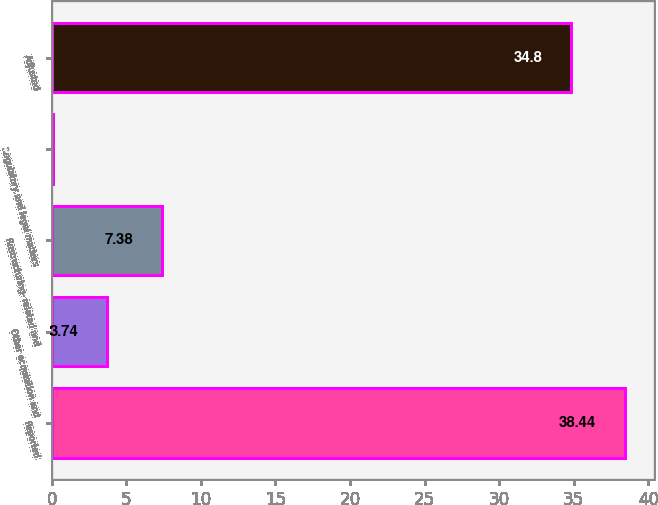<chart> <loc_0><loc_0><loc_500><loc_500><bar_chart><fcel>Reported<fcel>Other acquisition and<fcel>Restructuring- related and<fcel>Regulatory and legal matters<fcel>Adjusted<nl><fcel>38.44<fcel>3.74<fcel>7.38<fcel>0.1<fcel>34.8<nl></chart> 